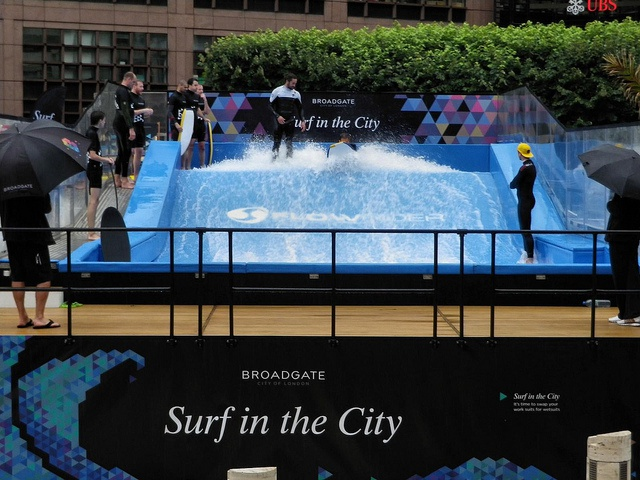Describe the objects in this image and their specific colors. I can see umbrella in gray and black tones, people in gray, black, maroon, brown, and darkgray tones, people in gray and black tones, umbrella in gray and black tones, and people in gray and black tones in this image. 